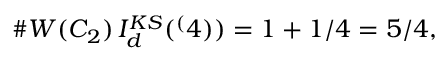<formula> <loc_0><loc_0><loc_500><loc_500>\# W ( C _ { 2 } ) \, I _ { d } ^ { K S } ( ^ { ( } 4 ) ) = 1 + 1 / 4 = 5 / 4 ,</formula> 